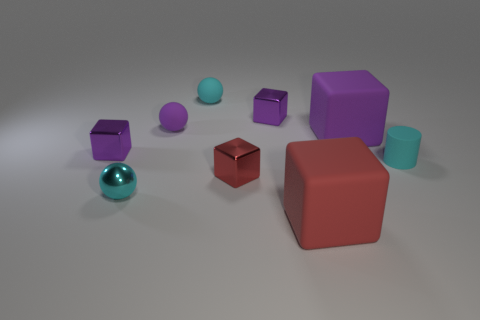How does the light source in the scene influence the appearance of the objects? The light source creates soft shadows and highlights reflective qualities of the objects, enhancing their three-dimensional forms and distinguishing the textures and colors. 